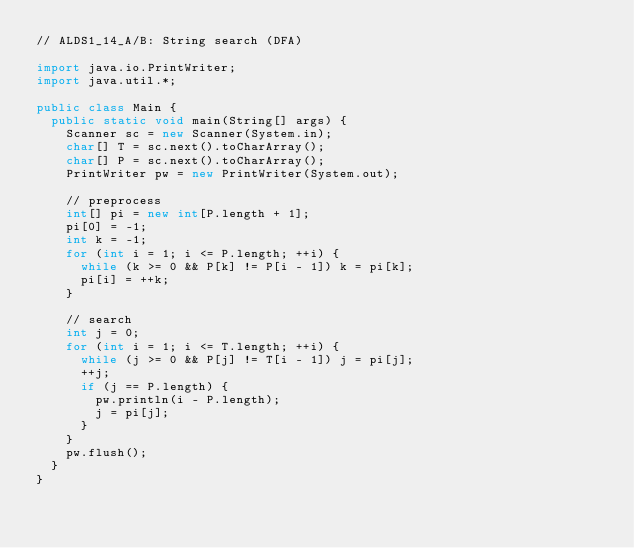Convert code to text. <code><loc_0><loc_0><loc_500><loc_500><_Java_>// ALDS1_14_A/B: String search (DFA)

import java.io.PrintWriter;
import java.util.*;

public class Main {
  public static void main(String[] args) {
    Scanner sc = new Scanner(System.in);
    char[] T = sc.next().toCharArray();
    char[] P = sc.next().toCharArray();
    PrintWriter pw = new PrintWriter(System.out);

    // preprocess
    int[] pi = new int[P.length + 1];
    pi[0] = -1;
    int k = -1;
    for (int i = 1; i <= P.length; ++i) {
      while (k >= 0 && P[k] != P[i - 1]) k = pi[k];
      pi[i] = ++k;
    }

    // search
    int j = 0;
    for (int i = 1; i <= T.length; ++i) {
      while (j >= 0 && P[j] != T[i - 1]) j = pi[j];
      ++j;
      if (j == P.length) {
        pw.println(i - P.length);
        j = pi[j];
      }
    }
    pw.flush();
  }
}
</code> 